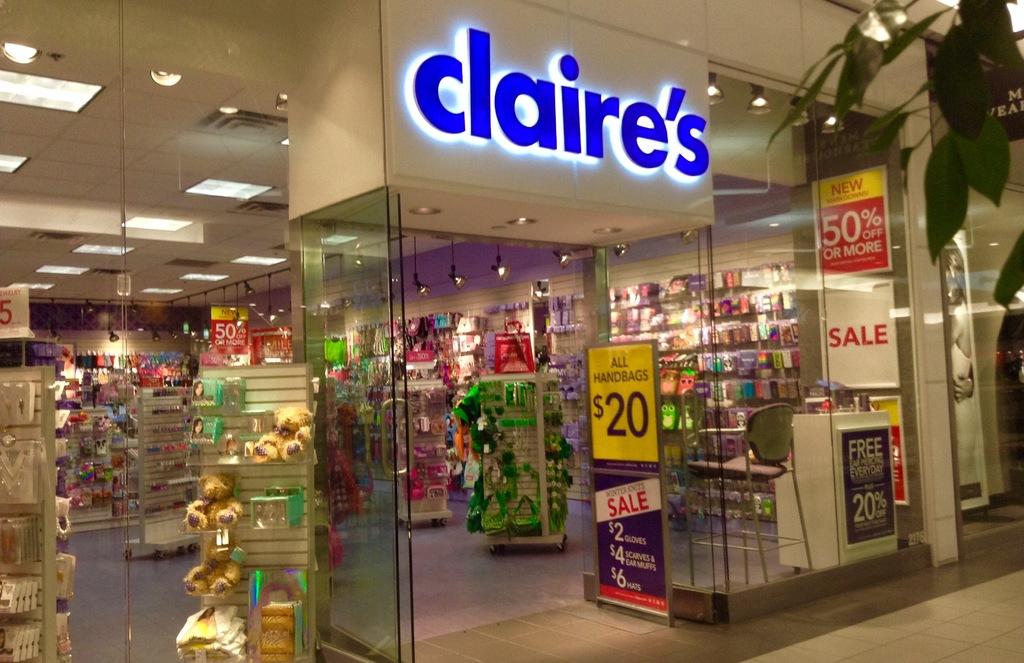What store is this?
Give a very brief answer. Claire's. What sale are they having?
Offer a terse response. 50%. 